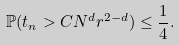<formula> <loc_0><loc_0><loc_500><loc_500>\mathbb { P } ( t _ { n } > C N ^ { d } r ^ { 2 - d } ) \leq \frac { 1 } { 4 } .</formula> 